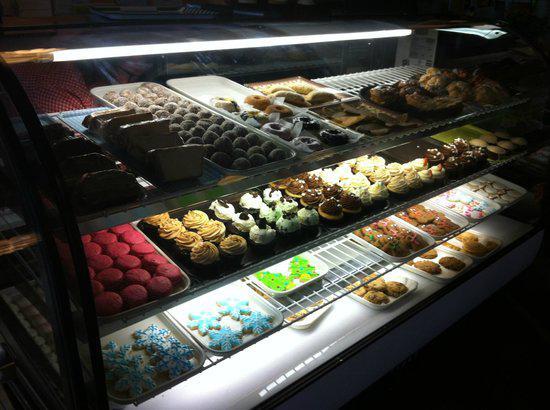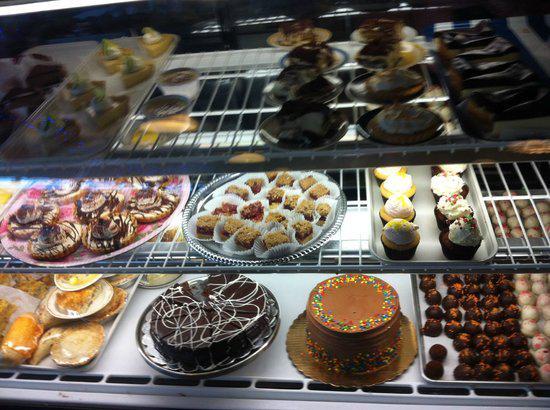The first image is the image on the left, the second image is the image on the right. Considering the images on both sides, is "There is a rounded display case." valid? Answer yes or no. No. 